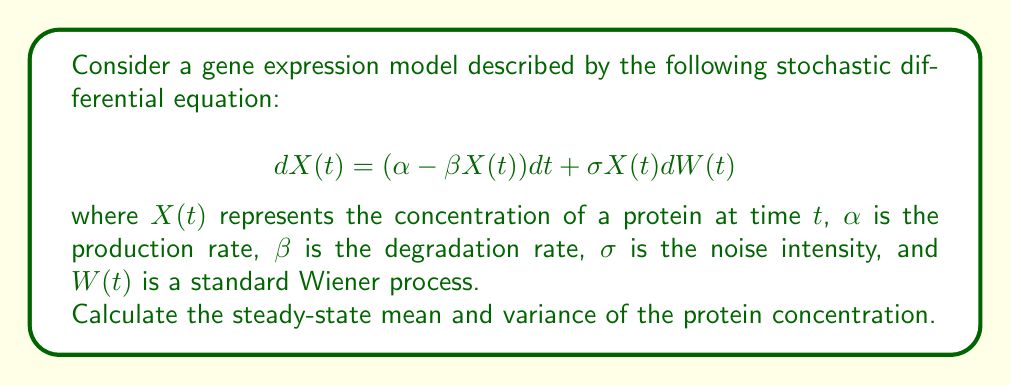Show me your answer to this math problem. To solve this problem, we'll follow these steps:

1) The steady-state mean ($\mu$) can be found by setting the drift term to zero:

   $$\alpha - \beta \mu = 0$$
   $$\mu = \frac{\alpha}{\beta}$$

2) For the variance, we can use Itô's formula to derive the equation for $d(X^2)$:

   $$d(X^2) = (2\alpha X - 2\beta X^2 + \sigma^2 X^2)dt + 2\sigma X^2 dW$$

3) Taking the expectation and setting it to zero for steady state:

   $$2\alpha E[X] - 2\beta E[X^2] + \sigma^2 E[X^2] = 0$$

4) Substitute $E[X] = \mu = \frac{\alpha}{\beta}$ and $E[X^2] = Var(X) + E[X]^2 = Var(X) + \mu^2$:

   $$2\alpha \frac{\alpha}{\beta} - 2\beta (Var(X) + (\frac{\alpha}{\beta})^2) + \sigma^2 (Var(X) + (\frac{\alpha}{\beta})^2) = 0$$

5) Simplify and solve for $Var(X)$:

   $$2\frac{\alpha^2}{\beta} - 2\beta Var(X) - 2\frac{\alpha^2}{\beta} + \sigma^2 Var(X) + \sigma^2 \frac{\alpha^2}{\beta^2} = 0$$
   
   $$(\sigma^2 - 2\beta) Var(X) = -\sigma^2 \frac{\alpha^2}{\beta^2}$$
   
   $$Var(X) = \frac{\sigma^2 \alpha^2}{\beta^2(2\beta - \sigma^2)}$$

Therefore, the steady-state mean is $\frac{\alpha}{\beta}$ and the steady-state variance is $\frac{\sigma^2 \alpha^2}{\beta^2(2\beta - \sigma^2)}$.
Answer: Mean: $\frac{\alpha}{\beta}$, Variance: $\frac{\sigma^2 \alpha^2}{\beta^2(2\beta - \sigma^2)}$ 